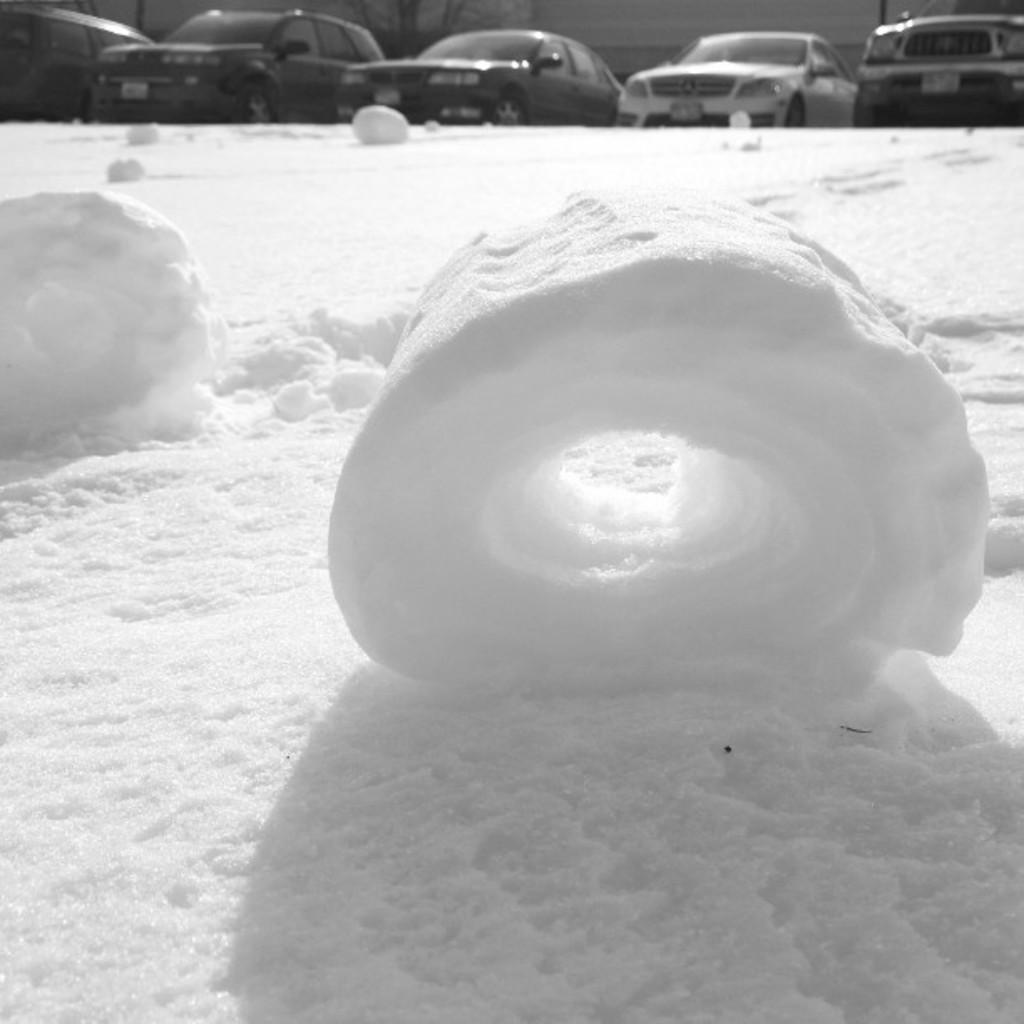Describe this image in one or two sentences. In this picture we can see snow, in the background we can find few cars. 